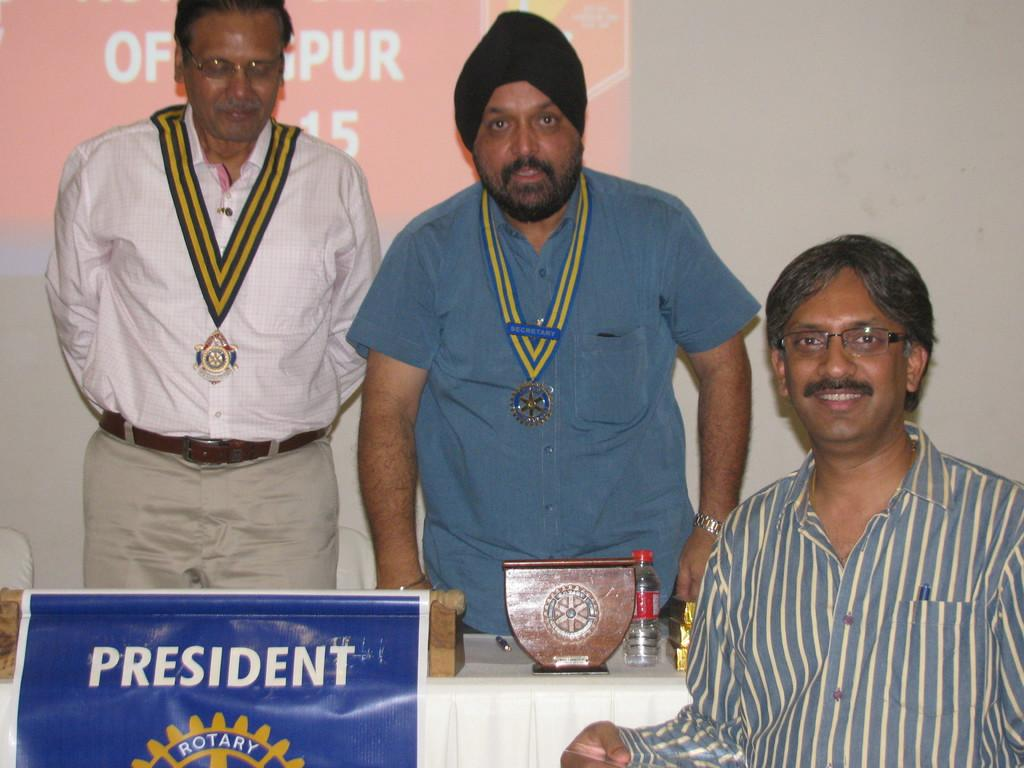Provide a one-sentence caption for the provided image. Two men stand while one sits behind a sign stating President. 